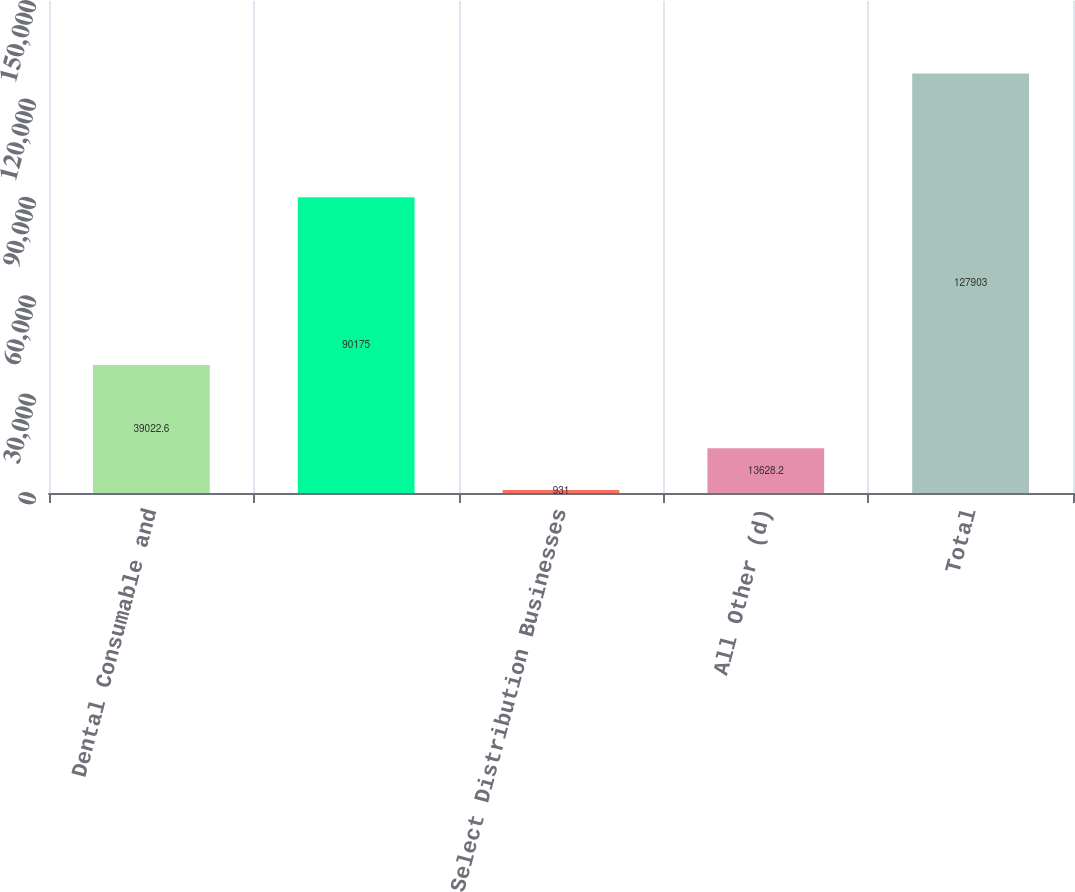<chart> <loc_0><loc_0><loc_500><loc_500><bar_chart><fcel>Dental Consumable and<fcel>Unnamed: 1<fcel>Select Distribution Businesses<fcel>All Other (d)<fcel>Total<nl><fcel>39022.6<fcel>90175<fcel>931<fcel>13628.2<fcel>127903<nl></chart> 